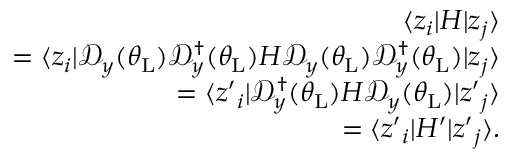Convert formula to latex. <formula><loc_0><loc_0><loc_500><loc_500>\begin{array} { r l r } & { \langle z _ { i } | H | z _ { j } \rangle } \\ & { = \langle z _ { i } | \mathcal { D } _ { y } ( \theta _ { L } ) \mathcal { D } _ { y } ^ { \dagger } ( \theta _ { L } ) H \mathcal { D } _ { y } ( \theta _ { L } ) \mathcal { D } _ { y } ^ { \dagger } ( \theta _ { L } ) | z _ { j } \rangle } \\ & { = \langle z { ^ { \prime } } _ { i } | \mathcal { D } _ { y } ^ { \dagger } ( \theta _ { L } ) H \mathcal { D } _ { y } ( \theta _ { L } ) | z { ^ { \prime } } _ { j } \rangle } \\ & { = \langle z { ^ { \prime } } _ { i } | H ^ { \prime } | z { ^ { \prime } } _ { j } \rangle . } \end{array}</formula> 